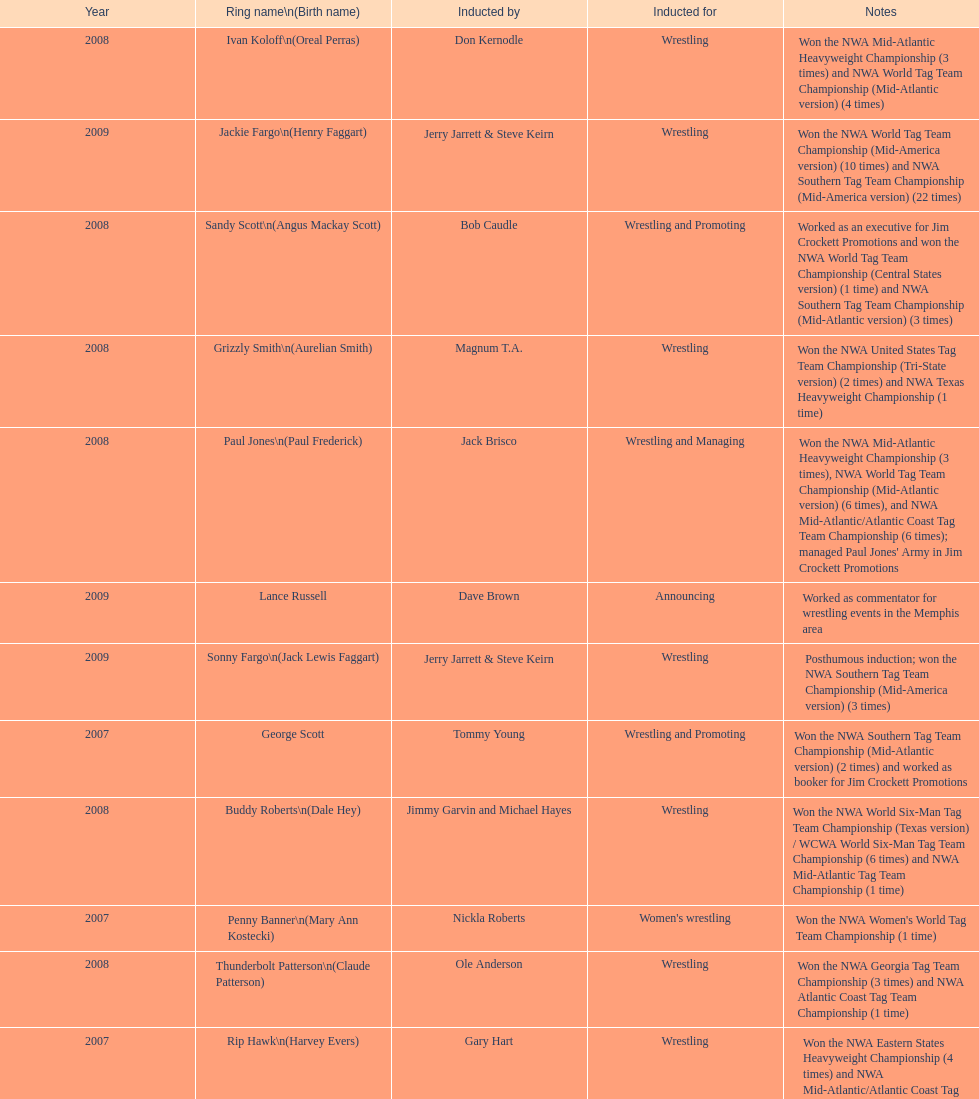Tell me an inductee that was not living at the time. Gene Anderson. 